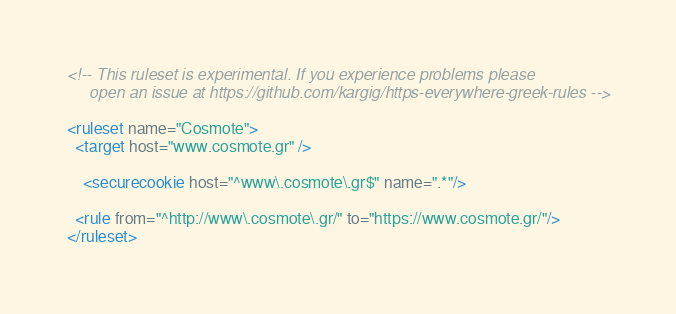Convert code to text. <code><loc_0><loc_0><loc_500><loc_500><_XML_><!-- This ruleset is experimental. If you experience problems please
	 open an issue at https://github.com/kargig/https-everywhere-greek-rules -->

<ruleset name="Cosmote">
  <target host="www.cosmote.gr" />

	<securecookie host="^www\.cosmote\.gr$" name=".*"/>

  <rule from="^http://www\.cosmote\.gr/" to="https://www.cosmote.gr/"/>
</ruleset>
</code> 